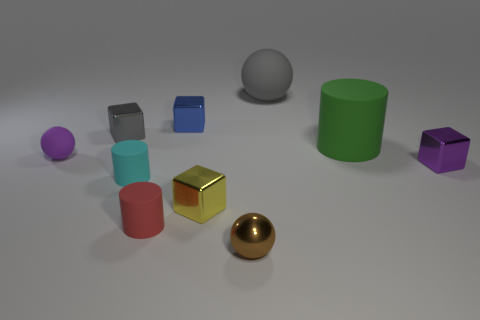The blue metal cube is what size?
Provide a short and direct response. Small. Is the number of red metal objects greater than the number of shiny balls?
Provide a short and direct response. No. What size is the matte thing that is to the right of the small red rubber thing and in front of the big matte sphere?
Your answer should be compact. Large. What material is the sphere that is behind the small purple thing behind the purple object to the right of the cyan object?
Give a very brief answer. Rubber. There is a rubber ball behind the green thing; is its color the same as the tiny shiny object that is left of the red cylinder?
Offer a terse response. Yes. The small purple object to the right of the purple thing that is behind the metal thing that is on the right side of the small brown shiny sphere is what shape?
Give a very brief answer. Cube. What shape is the tiny metallic object that is to the right of the gray shiny cube and behind the big green matte cylinder?
Provide a succinct answer. Cube. There is a shiny block that is to the right of the rubber thing that is behind the big cylinder; what number of blocks are behind it?
Offer a very short reply. 2. What is the size of the gray object that is the same shape as the purple matte thing?
Offer a terse response. Large. Is the large cylinder that is right of the cyan object made of the same material as the large gray thing?
Provide a short and direct response. Yes. 